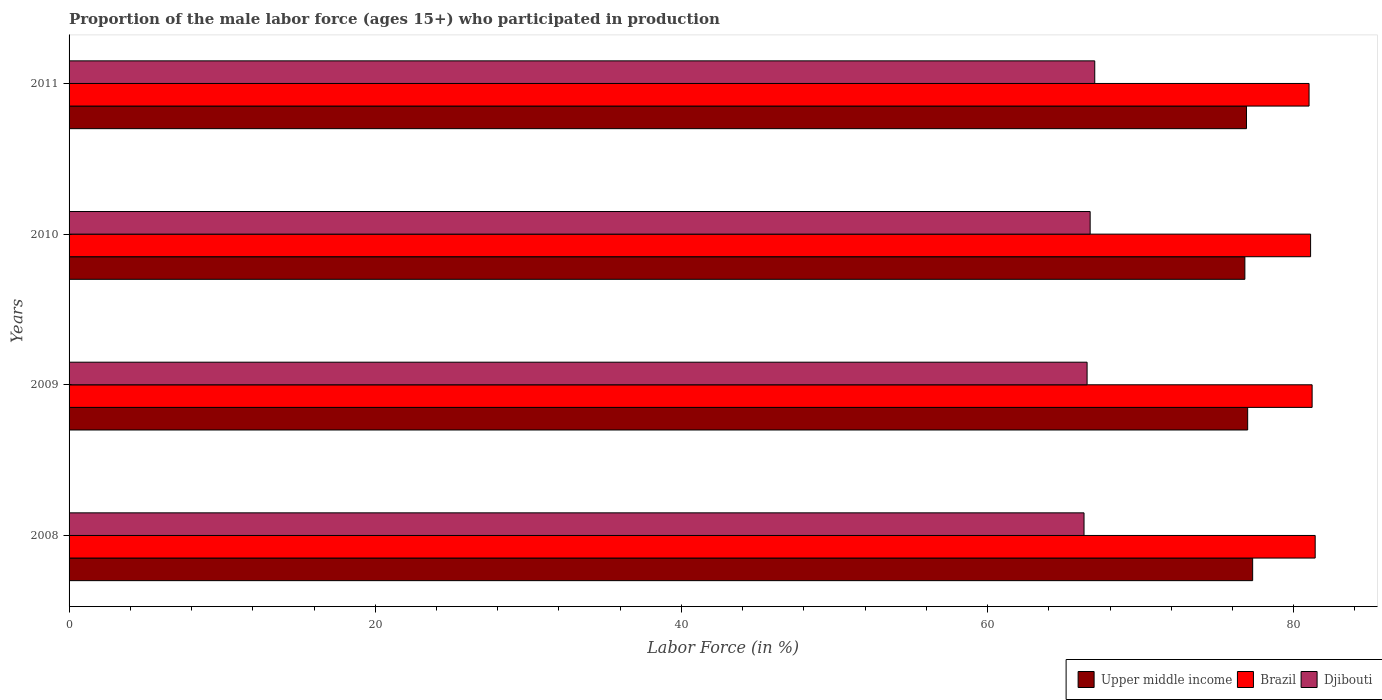How many different coloured bars are there?
Give a very brief answer. 3. Are the number of bars per tick equal to the number of legend labels?
Your answer should be compact. Yes. Are the number of bars on each tick of the Y-axis equal?
Make the answer very short. Yes. How many bars are there on the 3rd tick from the bottom?
Your response must be concise. 3. What is the label of the 1st group of bars from the top?
Keep it short and to the point. 2011. In how many cases, is the number of bars for a given year not equal to the number of legend labels?
Ensure brevity in your answer.  0. Across all years, what is the maximum proportion of the male labor force who participated in production in Upper middle income?
Offer a terse response. 77.31. Across all years, what is the minimum proportion of the male labor force who participated in production in Brazil?
Your response must be concise. 81. What is the total proportion of the male labor force who participated in production in Brazil in the graph?
Offer a terse response. 324.7. What is the difference between the proportion of the male labor force who participated in production in Brazil in 2008 and that in 2011?
Provide a short and direct response. 0.4. What is the difference between the proportion of the male labor force who participated in production in Upper middle income in 2011 and the proportion of the male labor force who participated in production in Djibouti in 2008?
Make the answer very short. 10.61. What is the average proportion of the male labor force who participated in production in Brazil per year?
Make the answer very short. 81.17. In the year 2011, what is the difference between the proportion of the male labor force who participated in production in Upper middle income and proportion of the male labor force who participated in production in Brazil?
Ensure brevity in your answer.  -4.09. In how many years, is the proportion of the male labor force who participated in production in Brazil greater than 28 %?
Your response must be concise. 4. What is the ratio of the proportion of the male labor force who participated in production in Brazil in 2009 to that in 2011?
Provide a short and direct response. 1. What is the difference between the highest and the second highest proportion of the male labor force who participated in production in Brazil?
Provide a succinct answer. 0.2. What is the difference between the highest and the lowest proportion of the male labor force who participated in production in Brazil?
Offer a terse response. 0.4. In how many years, is the proportion of the male labor force who participated in production in Brazil greater than the average proportion of the male labor force who participated in production in Brazil taken over all years?
Ensure brevity in your answer.  2. Is the sum of the proportion of the male labor force who participated in production in Upper middle income in 2010 and 2011 greater than the maximum proportion of the male labor force who participated in production in Djibouti across all years?
Offer a very short reply. Yes. What does the 1st bar from the top in 2010 represents?
Provide a succinct answer. Djibouti. What does the 3rd bar from the bottom in 2010 represents?
Make the answer very short. Djibouti. Is it the case that in every year, the sum of the proportion of the male labor force who participated in production in Upper middle income and proportion of the male labor force who participated in production in Brazil is greater than the proportion of the male labor force who participated in production in Djibouti?
Offer a very short reply. Yes. How many bars are there?
Offer a very short reply. 12. How many years are there in the graph?
Provide a succinct answer. 4. What is the difference between two consecutive major ticks on the X-axis?
Provide a short and direct response. 20. Does the graph contain any zero values?
Offer a very short reply. No. Does the graph contain grids?
Offer a very short reply. No. Where does the legend appear in the graph?
Offer a very short reply. Bottom right. How are the legend labels stacked?
Your answer should be compact. Horizontal. What is the title of the graph?
Provide a short and direct response. Proportion of the male labor force (ages 15+) who participated in production. Does "Latin America(developing only)" appear as one of the legend labels in the graph?
Offer a very short reply. No. What is the label or title of the X-axis?
Offer a very short reply. Labor Force (in %). What is the label or title of the Y-axis?
Give a very brief answer. Years. What is the Labor Force (in %) of Upper middle income in 2008?
Provide a short and direct response. 77.31. What is the Labor Force (in %) of Brazil in 2008?
Provide a succinct answer. 81.4. What is the Labor Force (in %) of Djibouti in 2008?
Keep it short and to the point. 66.3. What is the Labor Force (in %) of Upper middle income in 2009?
Your answer should be compact. 76.99. What is the Labor Force (in %) in Brazil in 2009?
Keep it short and to the point. 81.2. What is the Labor Force (in %) in Djibouti in 2009?
Your response must be concise. 66.5. What is the Labor Force (in %) in Upper middle income in 2010?
Your response must be concise. 76.81. What is the Labor Force (in %) of Brazil in 2010?
Ensure brevity in your answer.  81.1. What is the Labor Force (in %) in Djibouti in 2010?
Keep it short and to the point. 66.7. What is the Labor Force (in %) of Upper middle income in 2011?
Your response must be concise. 76.91. What is the Labor Force (in %) of Brazil in 2011?
Keep it short and to the point. 81. What is the Labor Force (in %) of Djibouti in 2011?
Offer a terse response. 67. Across all years, what is the maximum Labor Force (in %) in Upper middle income?
Keep it short and to the point. 77.31. Across all years, what is the maximum Labor Force (in %) in Brazil?
Offer a terse response. 81.4. Across all years, what is the minimum Labor Force (in %) in Upper middle income?
Ensure brevity in your answer.  76.81. Across all years, what is the minimum Labor Force (in %) of Brazil?
Provide a short and direct response. 81. Across all years, what is the minimum Labor Force (in %) in Djibouti?
Your response must be concise. 66.3. What is the total Labor Force (in %) in Upper middle income in the graph?
Provide a succinct answer. 308.02. What is the total Labor Force (in %) of Brazil in the graph?
Provide a succinct answer. 324.7. What is the total Labor Force (in %) in Djibouti in the graph?
Provide a succinct answer. 266.5. What is the difference between the Labor Force (in %) of Upper middle income in 2008 and that in 2009?
Offer a terse response. 0.32. What is the difference between the Labor Force (in %) of Brazil in 2008 and that in 2009?
Provide a short and direct response. 0.2. What is the difference between the Labor Force (in %) of Upper middle income in 2008 and that in 2010?
Keep it short and to the point. 0.51. What is the difference between the Labor Force (in %) of Brazil in 2008 and that in 2010?
Keep it short and to the point. 0.3. What is the difference between the Labor Force (in %) of Djibouti in 2008 and that in 2010?
Make the answer very short. -0.4. What is the difference between the Labor Force (in %) of Upper middle income in 2008 and that in 2011?
Your answer should be compact. 0.4. What is the difference between the Labor Force (in %) of Brazil in 2008 and that in 2011?
Your answer should be very brief. 0.4. What is the difference between the Labor Force (in %) in Djibouti in 2008 and that in 2011?
Your answer should be very brief. -0.7. What is the difference between the Labor Force (in %) of Upper middle income in 2009 and that in 2010?
Your answer should be compact. 0.18. What is the difference between the Labor Force (in %) of Brazil in 2009 and that in 2010?
Your answer should be very brief. 0.1. What is the difference between the Labor Force (in %) of Djibouti in 2009 and that in 2010?
Keep it short and to the point. -0.2. What is the difference between the Labor Force (in %) of Upper middle income in 2009 and that in 2011?
Offer a terse response. 0.08. What is the difference between the Labor Force (in %) of Brazil in 2009 and that in 2011?
Offer a very short reply. 0.2. What is the difference between the Labor Force (in %) in Djibouti in 2009 and that in 2011?
Offer a terse response. -0.5. What is the difference between the Labor Force (in %) of Upper middle income in 2010 and that in 2011?
Give a very brief answer. -0.11. What is the difference between the Labor Force (in %) in Upper middle income in 2008 and the Labor Force (in %) in Brazil in 2009?
Your answer should be compact. -3.89. What is the difference between the Labor Force (in %) of Upper middle income in 2008 and the Labor Force (in %) of Djibouti in 2009?
Provide a short and direct response. 10.81. What is the difference between the Labor Force (in %) of Upper middle income in 2008 and the Labor Force (in %) of Brazil in 2010?
Your response must be concise. -3.79. What is the difference between the Labor Force (in %) of Upper middle income in 2008 and the Labor Force (in %) of Djibouti in 2010?
Your answer should be very brief. 10.61. What is the difference between the Labor Force (in %) in Brazil in 2008 and the Labor Force (in %) in Djibouti in 2010?
Your response must be concise. 14.7. What is the difference between the Labor Force (in %) of Upper middle income in 2008 and the Labor Force (in %) of Brazil in 2011?
Offer a terse response. -3.69. What is the difference between the Labor Force (in %) of Upper middle income in 2008 and the Labor Force (in %) of Djibouti in 2011?
Give a very brief answer. 10.31. What is the difference between the Labor Force (in %) in Upper middle income in 2009 and the Labor Force (in %) in Brazil in 2010?
Keep it short and to the point. -4.11. What is the difference between the Labor Force (in %) of Upper middle income in 2009 and the Labor Force (in %) of Djibouti in 2010?
Ensure brevity in your answer.  10.29. What is the difference between the Labor Force (in %) in Brazil in 2009 and the Labor Force (in %) in Djibouti in 2010?
Ensure brevity in your answer.  14.5. What is the difference between the Labor Force (in %) in Upper middle income in 2009 and the Labor Force (in %) in Brazil in 2011?
Your response must be concise. -4.01. What is the difference between the Labor Force (in %) of Upper middle income in 2009 and the Labor Force (in %) of Djibouti in 2011?
Make the answer very short. 9.99. What is the difference between the Labor Force (in %) of Brazil in 2009 and the Labor Force (in %) of Djibouti in 2011?
Your answer should be compact. 14.2. What is the difference between the Labor Force (in %) of Upper middle income in 2010 and the Labor Force (in %) of Brazil in 2011?
Give a very brief answer. -4.19. What is the difference between the Labor Force (in %) in Upper middle income in 2010 and the Labor Force (in %) in Djibouti in 2011?
Make the answer very short. 9.81. What is the average Labor Force (in %) in Upper middle income per year?
Provide a short and direct response. 77.01. What is the average Labor Force (in %) in Brazil per year?
Provide a short and direct response. 81.17. What is the average Labor Force (in %) in Djibouti per year?
Offer a terse response. 66.62. In the year 2008, what is the difference between the Labor Force (in %) of Upper middle income and Labor Force (in %) of Brazil?
Make the answer very short. -4.09. In the year 2008, what is the difference between the Labor Force (in %) of Upper middle income and Labor Force (in %) of Djibouti?
Your answer should be compact. 11.01. In the year 2009, what is the difference between the Labor Force (in %) of Upper middle income and Labor Force (in %) of Brazil?
Keep it short and to the point. -4.21. In the year 2009, what is the difference between the Labor Force (in %) in Upper middle income and Labor Force (in %) in Djibouti?
Offer a terse response. 10.49. In the year 2009, what is the difference between the Labor Force (in %) of Brazil and Labor Force (in %) of Djibouti?
Give a very brief answer. 14.7. In the year 2010, what is the difference between the Labor Force (in %) of Upper middle income and Labor Force (in %) of Brazil?
Keep it short and to the point. -4.29. In the year 2010, what is the difference between the Labor Force (in %) in Upper middle income and Labor Force (in %) in Djibouti?
Provide a short and direct response. 10.11. In the year 2011, what is the difference between the Labor Force (in %) in Upper middle income and Labor Force (in %) in Brazil?
Offer a very short reply. -4.09. In the year 2011, what is the difference between the Labor Force (in %) in Upper middle income and Labor Force (in %) in Djibouti?
Offer a terse response. 9.91. What is the ratio of the Labor Force (in %) of Brazil in 2008 to that in 2009?
Your answer should be compact. 1. What is the ratio of the Labor Force (in %) in Djibouti in 2008 to that in 2009?
Offer a very short reply. 1. What is the ratio of the Labor Force (in %) in Upper middle income in 2008 to that in 2010?
Offer a terse response. 1.01. What is the ratio of the Labor Force (in %) in Brazil in 2008 to that in 2010?
Offer a very short reply. 1. What is the ratio of the Labor Force (in %) of Djibouti in 2008 to that in 2011?
Make the answer very short. 0.99. What is the ratio of the Labor Force (in %) of Upper middle income in 2009 to that in 2010?
Make the answer very short. 1. What is the ratio of the Labor Force (in %) of Upper middle income in 2009 to that in 2011?
Your answer should be compact. 1. What is the ratio of the Labor Force (in %) in Brazil in 2009 to that in 2011?
Keep it short and to the point. 1. What is the ratio of the Labor Force (in %) in Brazil in 2010 to that in 2011?
Keep it short and to the point. 1. What is the difference between the highest and the second highest Labor Force (in %) in Upper middle income?
Provide a short and direct response. 0.32. What is the difference between the highest and the lowest Labor Force (in %) in Upper middle income?
Your answer should be very brief. 0.51. What is the difference between the highest and the lowest Labor Force (in %) of Brazil?
Your answer should be compact. 0.4. 